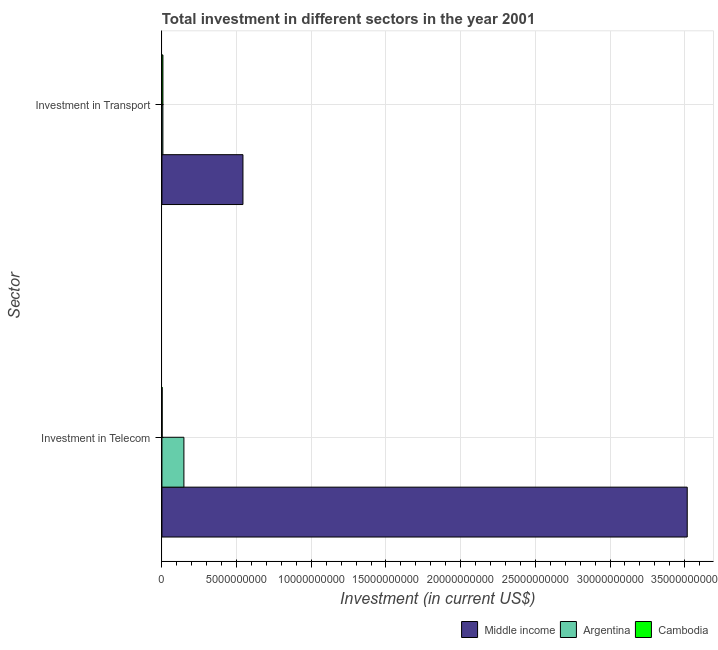How many different coloured bars are there?
Your answer should be compact. 3. Are the number of bars on each tick of the Y-axis equal?
Provide a succinct answer. Yes. How many bars are there on the 1st tick from the bottom?
Make the answer very short. 3. What is the label of the 2nd group of bars from the top?
Give a very brief answer. Investment in Telecom. What is the investment in telecom in Middle income?
Ensure brevity in your answer.  3.52e+1. Across all countries, what is the maximum investment in transport?
Your answer should be compact. 5.42e+09. Across all countries, what is the minimum investment in telecom?
Provide a short and direct response. 1.20e+07. In which country was the investment in telecom maximum?
Offer a terse response. Middle income. In which country was the investment in transport minimum?
Offer a terse response. Argentina. What is the total investment in telecom in the graph?
Your answer should be very brief. 3.67e+1. What is the difference between the investment in transport in Middle income and that in Argentina?
Offer a very short reply. 5.36e+09. What is the difference between the investment in telecom in Cambodia and the investment in transport in Argentina?
Offer a terse response. -5.15e+07. What is the average investment in telecom per country?
Provide a short and direct response. 1.22e+1. What is the difference between the investment in transport and investment in telecom in Cambodia?
Provide a succinct answer. 5.30e+07. What is the ratio of the investment in transport in Argentina to that in Middle income?
Offer a very short reply. 0.01. Is the investment in telecom in Cambodia less than that in Middle income?
Your answer should be compact. Yes. What does the 1st bar from the top in Investment in Transport represents?
Keep it short and to the point. Cambodia. What does the 3rd bar from the bottom in Investment in Telecom represents?
Offer a very short reply. Cambodia. How many bars are there?
Ensure brevity in your answer.  6. How many countries are there in the graph?
Make the answer very short. 3. What is the difference between two consecutive major ticks on the X-axis?
Provide a short and direct response. 5.00e+09. Are the values on the major ticks of X-axis written in scientific E-notation?
Keep it short and to the point. No. Does the graph contain grids?
Your answer should be very brief. Yes. Where does the legend appear in the graph?
Your response must be concise. Bottom right. How many legend labels are there?
Your answer should be compact. 3. What is the title of the graph?
Give a very brief answer. Total investment in different sectors in the year 2001. Does "Puerto Rico" appear as one of the legend labels in the graph?
Offer a very short reply. No. What is the label or title of the X-axis?
Provide a succinct answer. Investment (in current US$). What is the label or title of the Y-axis?
Give a very brief answer. Sector. What is the Investment (in current US$) of Middle income in Investment in Telecom?
Make the answer very short. 3.52e+1. What is the Investment (in current US$) of Argentina in Investment in Telecom?
Provide a short and direct response. 1.47e+09. What is the Investment (in current US$) of Cambodia in Investment in Telecom?
Your answer should be very brief. 1.20e+07. What is the Investment (in current US$) of Middle income in Investment in Transport?
Your answer should be very brief. 5.42e+09. What is the Investment (in current US$) in Argentina in Investment in Transport?
Your answer should be compact. 6.35e+07. What is the Investment (in current US$) in Cambodia in Investment in Transport?
Ensure brevity in your answer.  6.50e+07. Across all Sector, what is the maximum Investment (in current US$) of Middle income?
Your answer should be compact. 3.52e+1. Across all Sector, what is the maximum Investment (in current US$) of Argentina?
Give a very brief answer. 1.47e+09. Across all Sector, what is the maximum Investment (in current US$) of Cambodia?
Offer a very short reply. 6.50e+07. Across all Sector, what is the minimum Investment (in current US$) in Middle income?
Keep it short and to the point. 5.42e+09. Across all Sector, what is the minimum Investment (in current US$) in Argentina?
Your answer should be very brief. 6.35e+07. What is the total Investment (in current US$) of Middle income in the graph?
Provide a short and direct response. 4.06e+1. What is the total Investment (in current US$) of Argentina in the graph?
Your response must be concise. 1.53e+09. What is the total Investment (in current US$) of Cambodia in the graph?
Provide a succinct answer. 7.70e+07. What is the difference between the Investment (in current US$) in Middle income in Investment in Telecom and that in Investment in Transport?
Ensure brevity in your answer.  2.97e+1. What is the difference between the Investment (in current US$) in Argentina in Investment in Telecom and that in Investment in Transport?
Make the answer very short. 1.41e+09. What is the difference between the Investment (in current US$) of Cambodia in Investment in Telecom and that in Investment in Transport?
Your answer should be compact. -5.30e+07. What is the difference between the Investment (in current US$) in Middle income in Investment in Telecom and the Investment (in current US$) in Argentina in Investment in Transport?
Make the answer very short. 3.51e+1. What is the difference between the Investment (in current US$) of Middle income in Investment in Telecom and the Investment (in current US$) of Cambodia in Investment in Transport?
Provide a short and direct response. 3.51e+1. What is the difference between the Investment (in current US$) in Argentina in Investment in Telecom and the Investment (in current US$) in Cambodia in Investment in Transport?
Provide a short and direct response. 1.41e+09. What is the average Investment (in current US$) in Middle income per Sector?
Keep it short and to the point. 2.03e+1. What is the average Investment (in current US$) of Argentina per Sector?
Your answer should be very brief. 7.67e+08. What is the average Investment (in current US$) in Cambodia per Sector?
Give a very brief answer. 3.85e+07. What is the difference between the Investment (in current US$) in Middle income and Investment (in current US$) in Argentina in Investment in Telecom?
Provide a short and direct response. 3.37e+1. What is the difference between the Investment (in current US$) of Middle income and Investment (in current US$) of Cambodia in Investment in Telecom?
Your response must be concise. 3.52e+1. What is the difference between the Investment (in current US$) in Argentina and Investment (in current US$) in Cambodia in Investment in Telecom?
Your answer should be compact. 1.46e+09. What is the difference between the Investment (in current US$) of Middle income and Investment (in current US$) of Argentina in Investment in Transport?
Keep it short and to the point. 5.36e+09. What is the difference between the Investment (in current US$) of Middle income and Investment (in current US$) of Cambodia in Investment in Transport?
Offer a terse response. 5.36e+09. What is the difference between the Investment (in current US$) in Argentina and Investment (in current US$) in Cambodia in Investment in Transport?
Provide a short and direct response. -1.50e+06. What is the ratio of the Investment (in current US$) of Middle income in Investment in Telecom to that in Investment in Transport?
Provide a short and direct response. 6.48. What is the ratio of the Investment (in current US$) in Argentina in Investment in Telecom to that in Investment in Transport?
Offer a terse response. 23.15. What is the ratio of the Investment (in current US$) in Cambodia in Investment in Telecom to that in Investment in Transport?
Provide a succinct answer. 0.18. What is the difference between the highest and the second highest Investment (in current US$) of Middle income?
Keep it short and to the point. 2.97e+1. What is the difference between the highest and the second highest Investment (in current US$) of Argentina?
Offer a very short reply. 1.41e+09. What is the difference between the highest and the second highest Investment (in current US$) of Cambodia?
Your response must be concise. 5.30e+07. What is the difference between the highest and the lowest Investment (in current US$) of Middle income?
Keep it short and to the point. 2.97e+1. What is the difference between the highest and the lowest Investment (in current US$) of Argentina?
Your answer should be compact. 1.41e+09. What is the difference between the highest and the lowest Investment (in current US$) of Cambodia?
Offer a very short reply. 5.30e+07. 